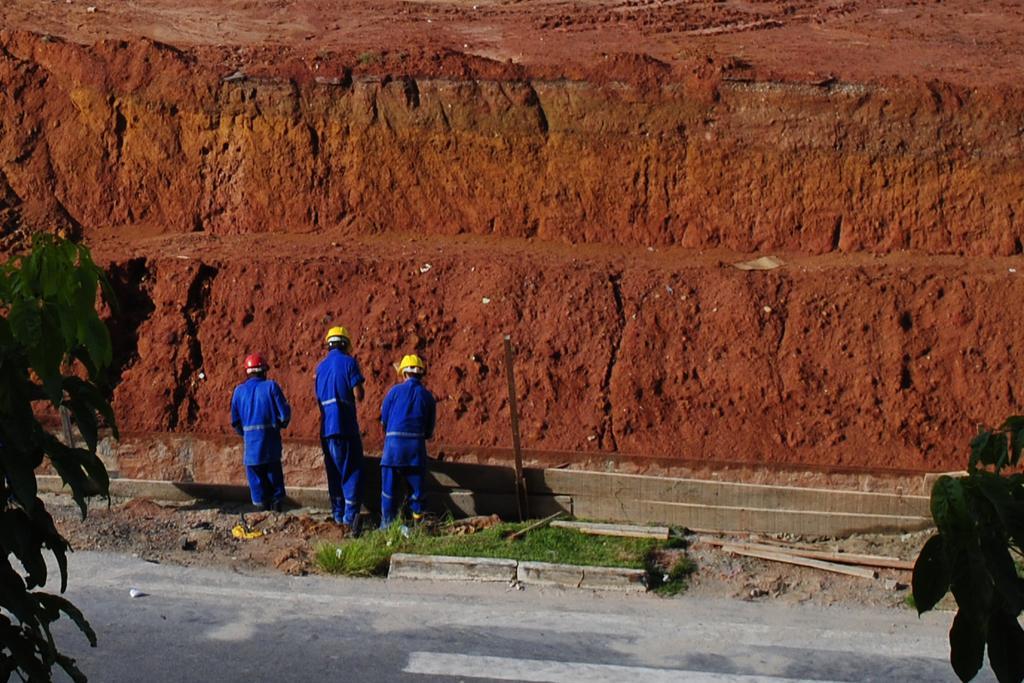How would you summarize this image in a sentence or two? In this image we can see three persons wearing the blue dress, there are trees, in the background we can see red mud dune. 